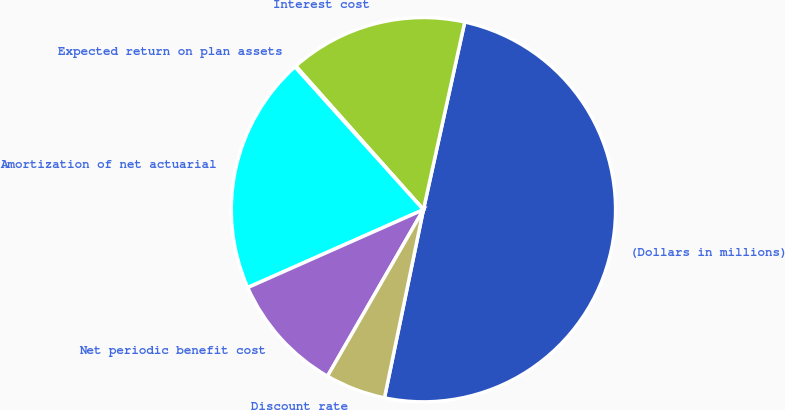Convert chart. <chart><loc_0><loc_0><loc_500><loc_500><pie_chart><fcel>(Dollars in millions)<fcel>Interest cost<fcel>Expected return on plan assets<fcel>Amortization of net actuarial<fcel>Net periodic benefit cost<fcel>Discount rate<nl><fcel>49.8%<fcel>15.01%<fcel>0.1%<fcel>19.98%<fcel>10.04%<fcel>5.07%<nl></chart> 